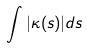Convert formula to latex. <formula><loc_0><loc_0><loc_500><loc_500>\int | \kappa ( s ) | d s</formula> 